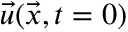Convert formula to latex. <formula><loc_0><loc_0><loc_500><loc_500>\ V e c { u } ( \ V e c { x } , t = 0 )</formula> 